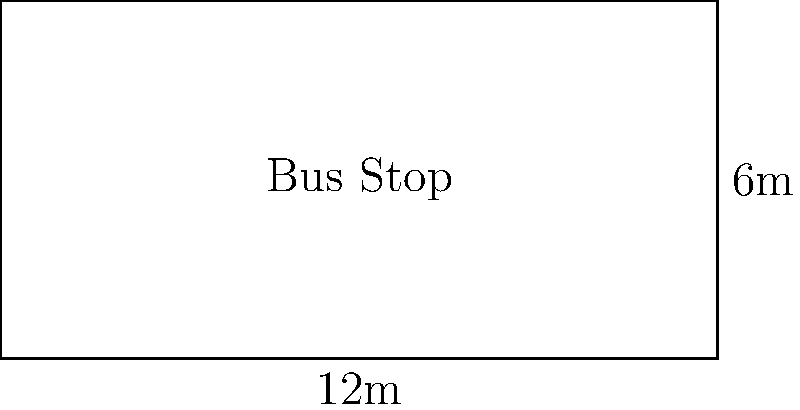A rectangular bus stop measures 12 meters in length and 6 meters in width. If each passenger requires a minimum of 1.5 square meters of space, what is the maximum number of passengers that can safely wait at this bus stop? To solve this problem, we need to follow these steps:

1. Calculate the area of the bus stop:
   Area = Length × Width
   $$ A = 12 \text{ m} \times 6 \text{ m} = 72 \text{ m}^2 $$

2. Determine the space required per passenger:
   Each passenger needs 1.5 square meters

3. Calculate the maximum number of passengers:
   Maximum passengers = Total area ÷ Space per passenger
   $$ \text{Max passengers} = \frac{72 \text{ m}^2}{1.5 \text{ m}^2/\text{person}} = 48 \text{ people} $$

4. Since we can't have a fractional number of people, we round down to the nearest whole number.

Therefore, the maximum number of passengers that can safely wait at this bus stop is 48.
Answer: 48 passengers 